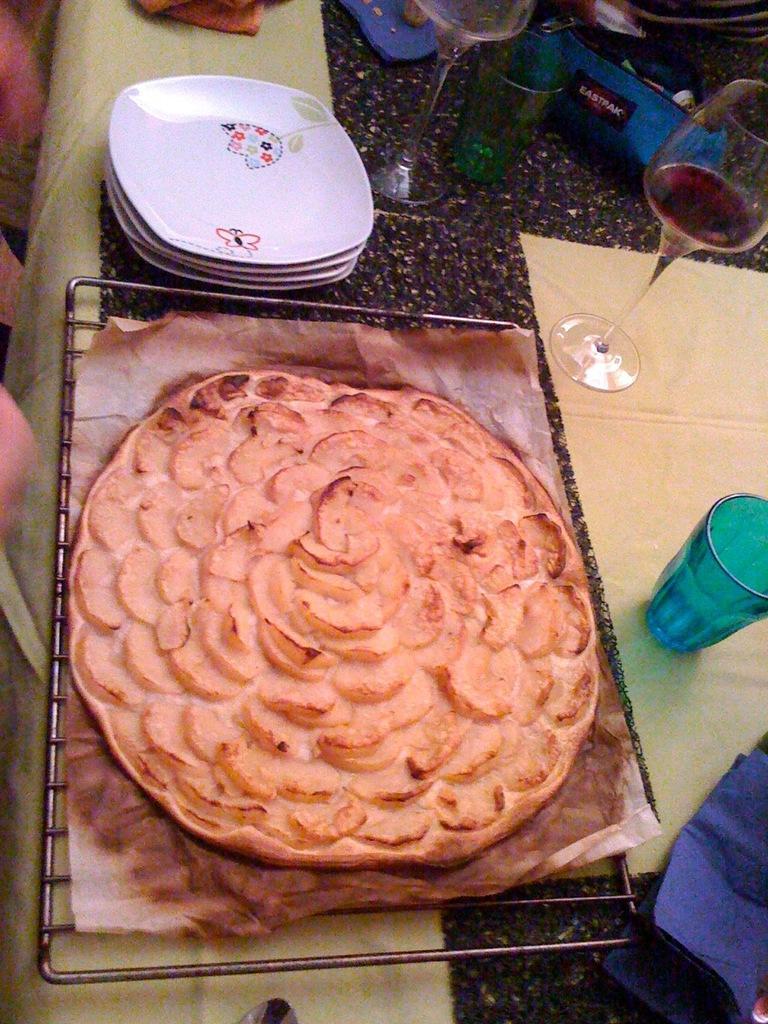Can you describe this image briefly? In this image we can see some food on a grill. We can also see some plates, glasses, bottles, paper and a cloth which are placed on the table. 